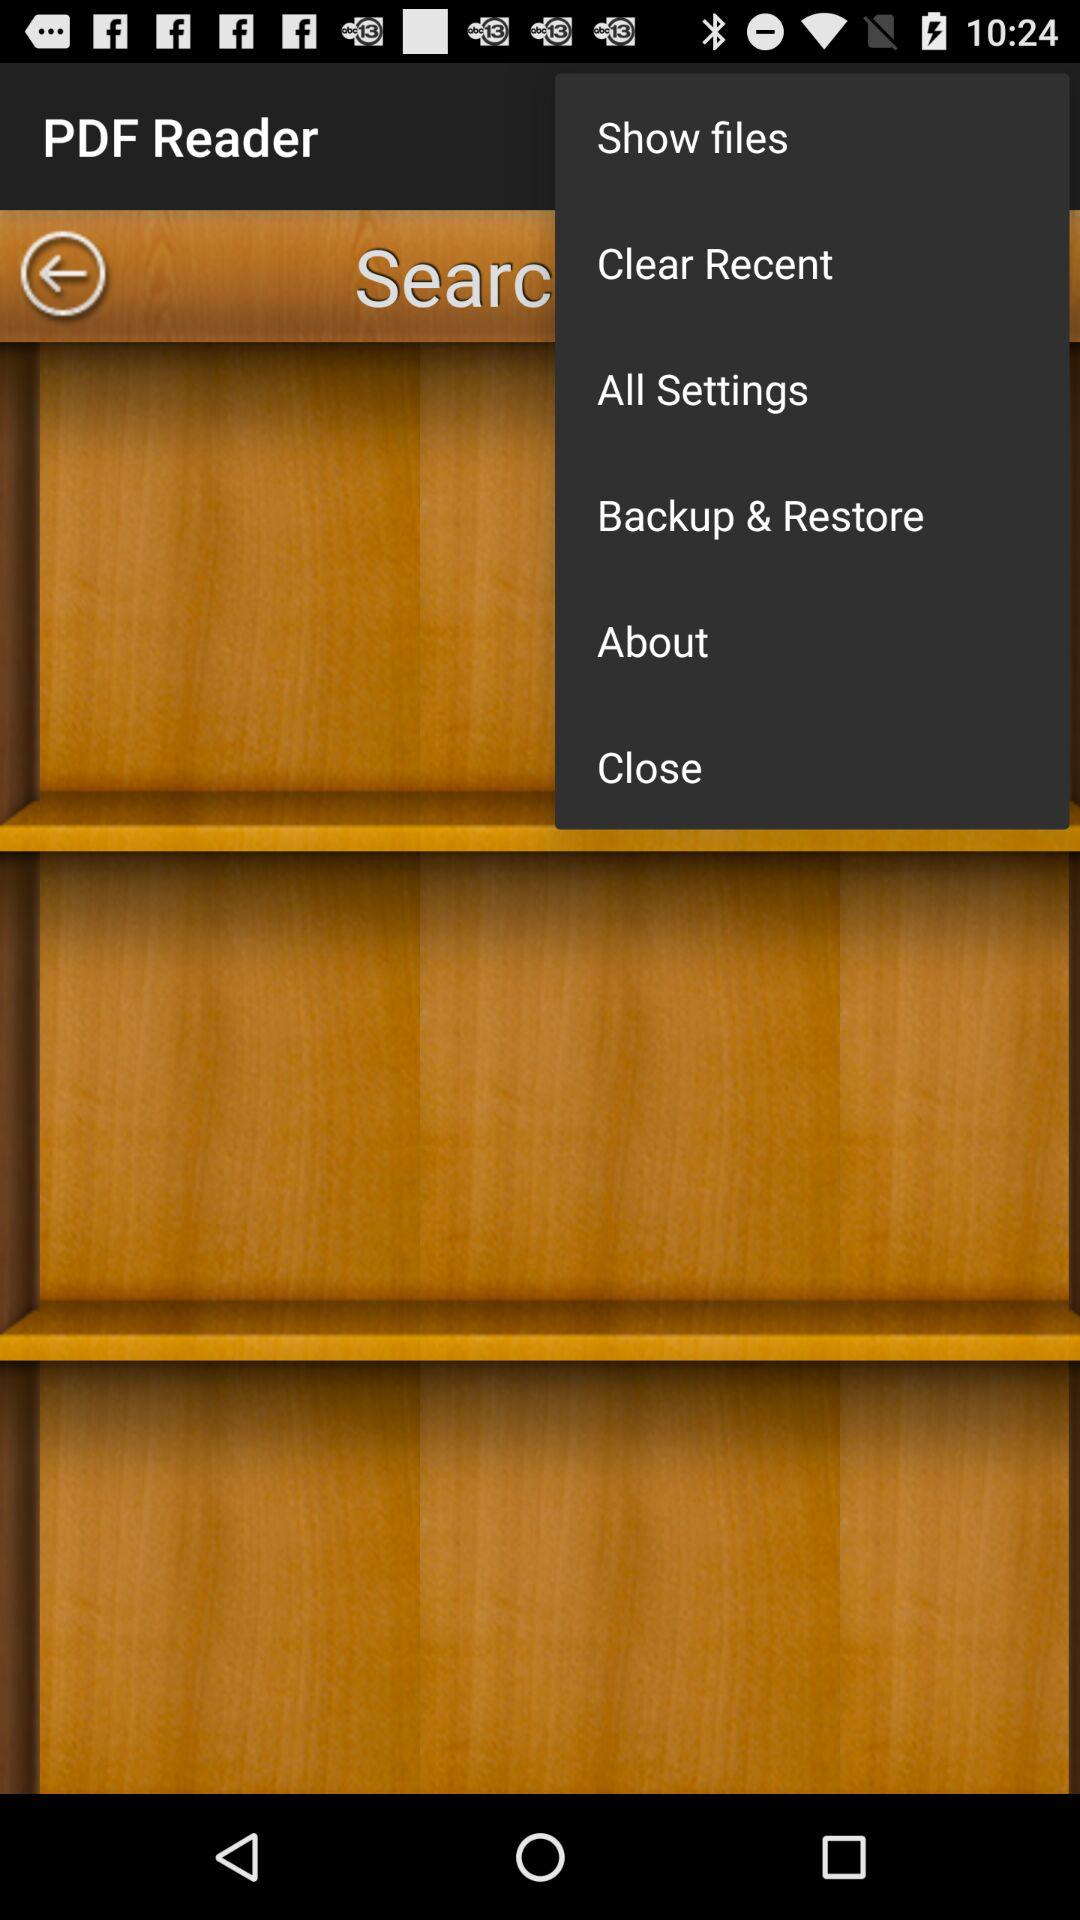What is the name of the application? The name of the application is "PDF Reader". 